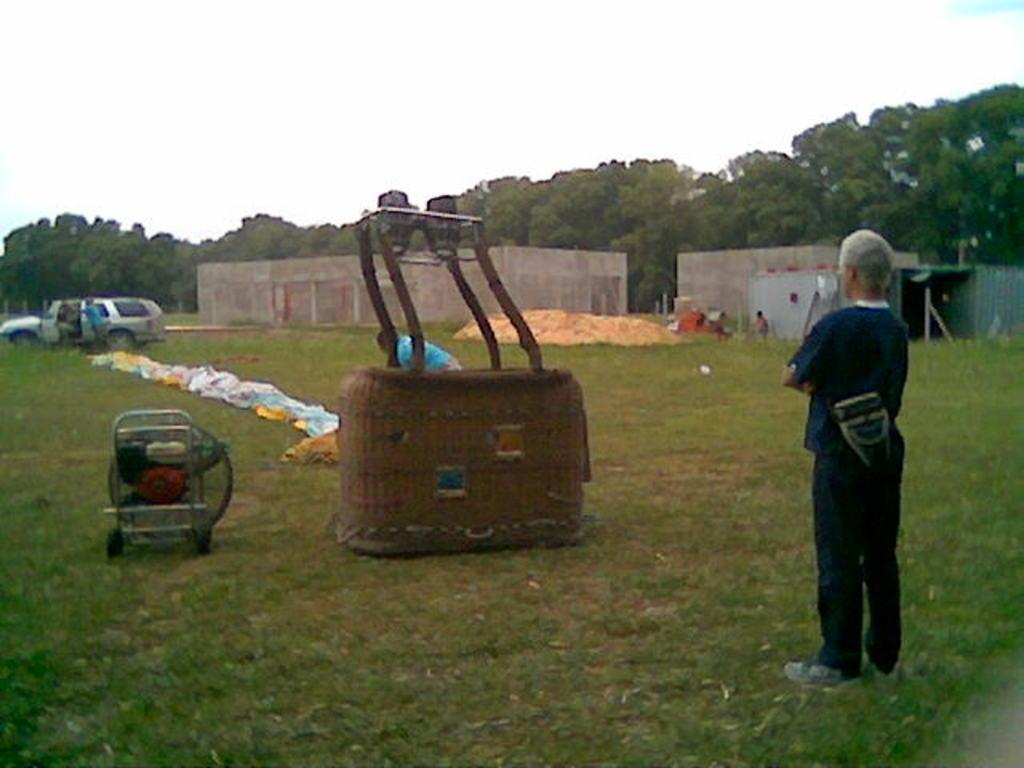What is the person in the image standing on? The person is standing on the grass. What else can be seen on the grass in the image? There are objects on the grass. What can be seen in the background of the image? There is a vehicle, people, houses, and trees visible in the background. What type of mark can be seen on the person's underwear in the image? There is no mention of underwear or any mark on it in the provided facts, so we cannot answer this question based on the image. 